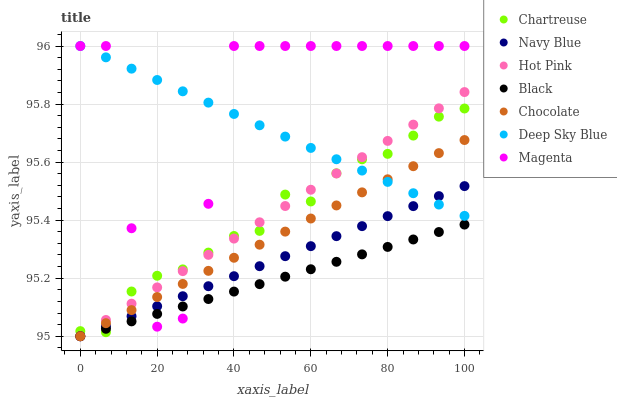Does Black have the minimum area under the curve?
Answer yes or no. Yes. Does Magenta have the maximum area under the curve?
Answer yes or no. Yes. Does Hot Pink have the minimum area under the curve?
Answer yes or no. No. Does Hot Pink have the maximum area under the curve?
Answer yes or no. No. Is Hot Pink the smoothest?
Answer yes or no. Yes. Is Magenta the roughest?
Answer yes or no. Yes. Is Chocolate the smoothest?
Answer yes or no. No. Is Chocolate the roughest?
Answer yes or no. No. Does Navy Blue have the lowest value?
Answer yes or no. Yes. Does Chartreuse have the lowest value?
Answer yes or no. No. Does Magenta have the highest value?
Answer yes or no. Yes. Does Hot Pink have the highest value?
Answer yes or no. No. Is Black less than Deep Sky Blue?
Answer yes or no. Yes. Is Deep Sky Blue greater than Black?
Answer yes or no. Yes. Does Hot Pink intersect Deep Sky Blue?
Answer yes or no. Yes. Is Hot Pink less than Deep Sky Blue?
Answer yes or no. No. Is Hot Pink greater than Deep Sky Blue?
Answer yes or no. No. Does Black intersect Deep Sky Blue?
Answer yes or no. No. 